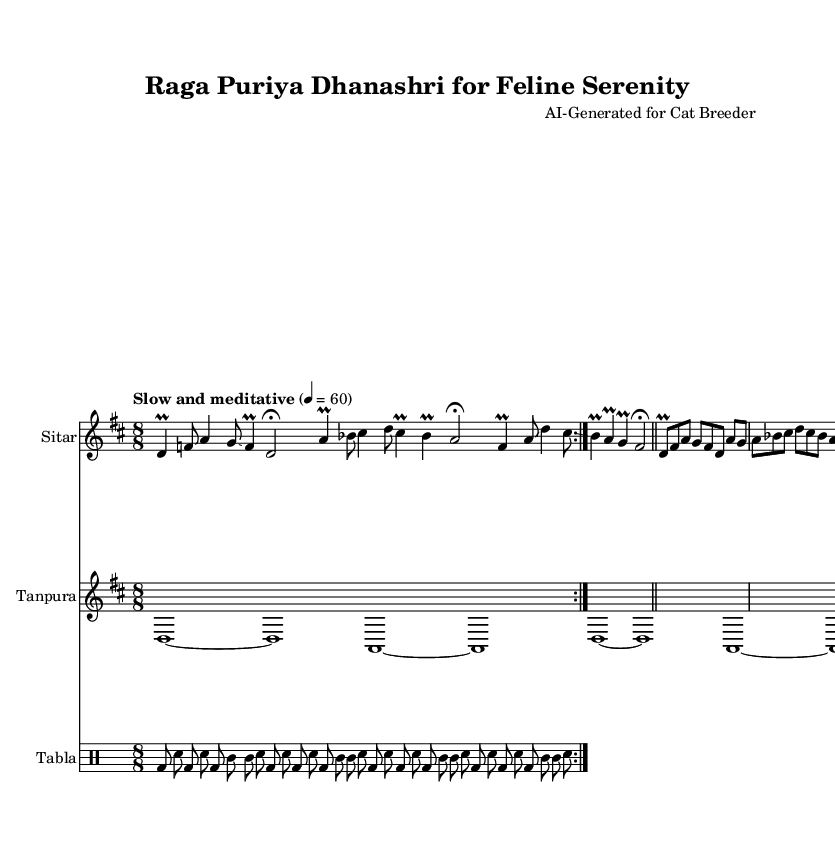What is the key signature of this music? The key signature is indicated by the sharps or flats at the beginning of the staff. In this score, it shows one sharp, which corresponds to D major or B minor.
Answer: D major What is the time signature of this music? The time signature is displayed as a fraction at the beginning of the score, specifically above the staff. Here, it shows "8/8", meaning there are eight eighth notes per measure.
Answer: 8/8 What is the tempo marking of this music? The tempo marking is typically found above the staff and indicates the speed of the piece. In this case, it states "Slow and meditative" with a metronome marking of 60 beats per minute.
Answer: Slow and meditative How many sections are present in the Raga? By analyzing the structure of the raga, it consists of two main sections: Alap and Jor, which are both distinguished in the score.
Answer: 2 What is the instrument that plays the main melodic line? The instrument that plays the main melodic line is indicated at the beginning of the relevant staff, showing "Sitar".
Answer: Sitar How many times is the tabla pattern repeated? The repetition of the tabla pattern can be identified by the notation indicating "volta" sections. The score shows that it is repeated twice.
Answer: 2 What is the function of the tanpura in this piece? The tanpura provides a drone throughout the performance, sustaining certain notes to create an atmospheric background. Its pattern reinforces the tonality.
Answer: Drone 